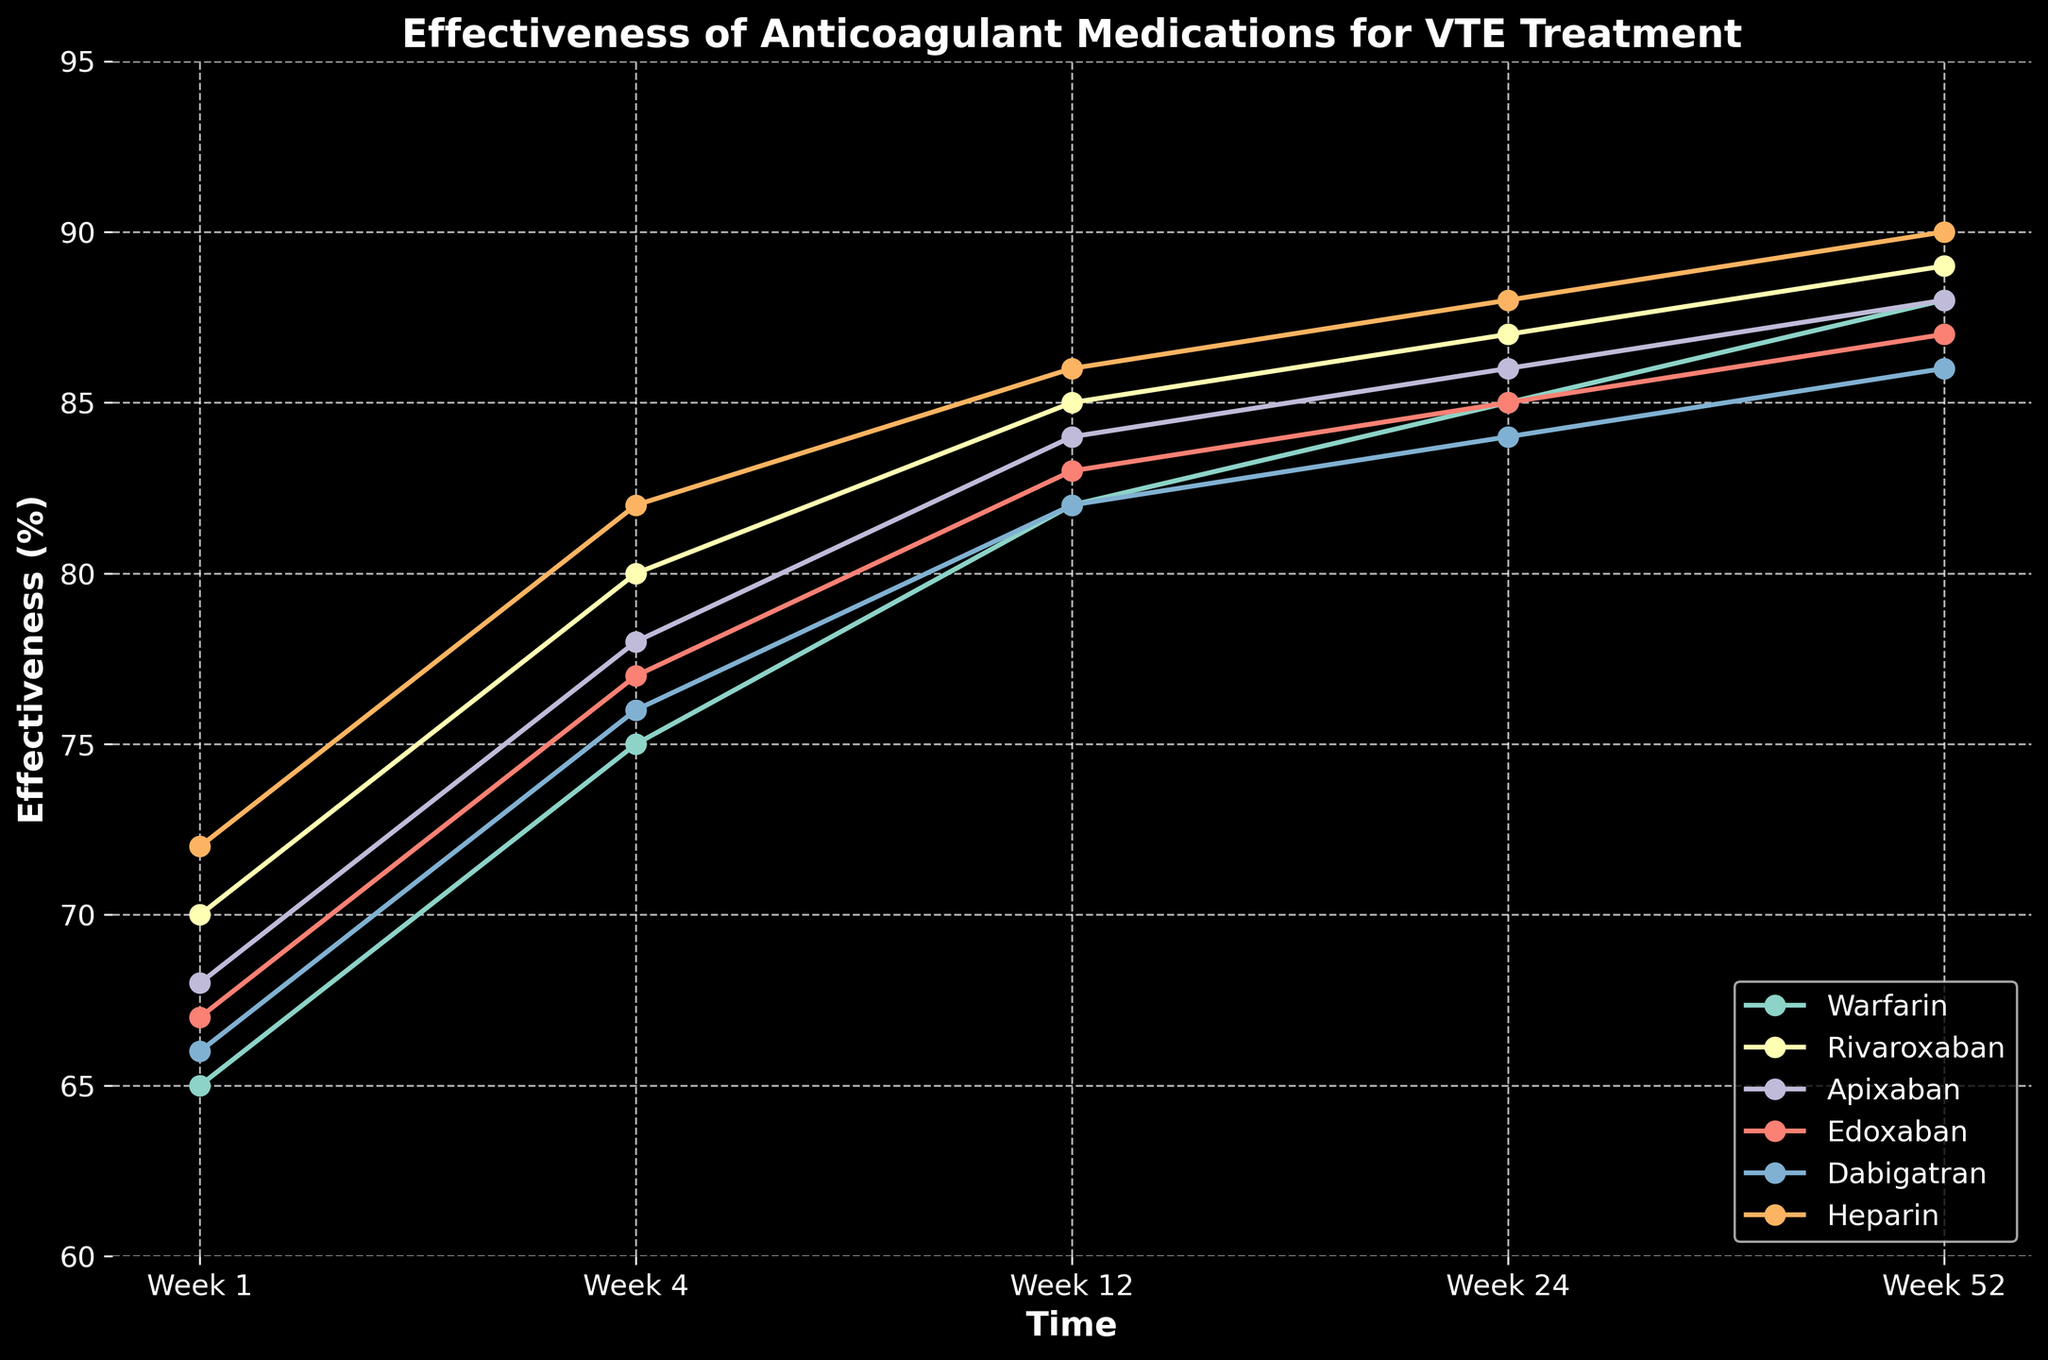What's the most effective drug at Week 1? By observing the chart, the effectiveness of each drug at Week 1 can be compared. The highest effectiveness value at Week 1 is for Heparin.
Answer: Heparin How does Rivaroxaban's effectiveness compare to Apixaban's at Week 12? By comparing the effectiveness values of Rivaroxaban and Apixaban at Week 12 on the chart, Rivaroxaban has an effectiveness of 85% while Apixaban has 84%.
Answer: Rivaroxaban is more effective by 1% Which drug shows the least increase in effectiveness from Week 1 to Week 52? Calculate the effectiveness increase for each drug from Week 1 to Week 52 and compare the values. Warfarin: 88-65=23, Rivaroxaban: 89-70=19, Apixaban: 88-68=20, Edoxaban: 87-67=20, Dabigatran: 86-66=20, Heparin: 90-72=18. Heparin shows the smallest increase of 18.
Answer: Heparin with an increase of 18% What's the effectiveness range of Warfarin during the time period shown? The range is calculated by subtracting the minimum effectiveness from the maximum effectiveness of Warfarin over the period. Warfarin's values are 65, 75, 82, 85, and 88. The range is 88-65=23.
Answer: 23% Which drug had the highest effectiveness at Week 24? Observing the effectiveness values at Week 24, Heparin has the highest effectiveness at Week 24 with a value of 88%.
Answer: Heparin What's the average effectiveness of Edoxaban over the 5 time points? The average is calculated by summing Edoxaban's effectiveness values (67, 77, 83, 85, 87) and dividing by the number of values. (67+77+83+85+87)/5 = 399/5 = 79.8
Answer: 79.8% By how much does Dabigatran's effectiveness increase from Week 24 to Week 52? Dabigatran's effectiveness at Week 24 is 84 and at Week 52 is 86. The increase is calculated by subtracting the Week 24 value from the Week 52 value, 86-84=2.
Answer: Increases by 2% Which two drugs show the same effectiveness at any point during the observed period? By evaluating the chart, Warfarin and Apixaban both show an effectiveness of 88% at Week 52.
Answer: Warfarin and Apixaban at Week 52 What's the difference in effectiveness between Heparin and Warfarin at Week 4? The effectiveness of Heparin at Week 4 is 82% and Warfarin at Week 4 is 75%. The difference is calculated by subtracting Warfarin's value from Heparin's value, 82-75=7.
Answer: 7% Which drug maintains the most consistent effectiveness (smallest range) over the 5 time points? Calculate the range of effectiveness for each drug: Warfarin (88-65=23), Rivaroxaban (89-70=19), Apixaban (88-68=20), Edoxaban (87-67=20), Dabigatran (86-66=20), Heparin (90-72=18). Heparin has the smallest range of 18.
Answer: Heparin 